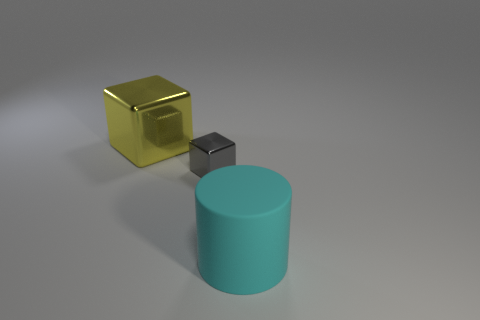Add 2 small gray blocks. How many objects exist? 5 Add 1 cyan blocks. How many cyan blocks exist? 1 Subtract all gray blocks. How many blocks are left? 1 Subtract 0 cyan balls. How many objects are left? 3 Subtract all blocks. How many objects are left? 1 Subtract 1 blocks. How many blocks are left? 1 Subtract all cyan blocks. Subtract all red spheres. How many blocks are left? 2 Subtract all gray balls. How many yellow cubes are left? 1 Subtract all tiny gray objects. Subtract all small purple objects. How many objects are left? 2 Add 1 gray objects. How many gray objects are left? 2 